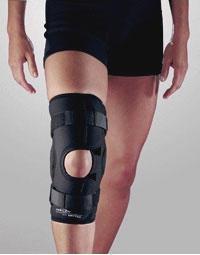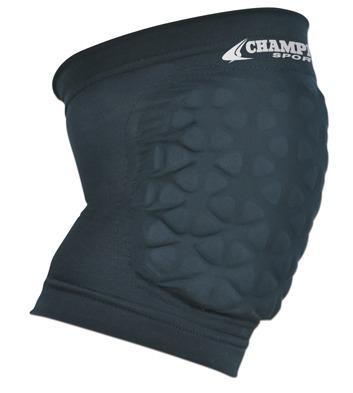The first image is the image on the left, the second image is the image on the right. Assess this claim about the two images: "one of the male legs has a brace, the other is bare". Correct or not? Answer yes or no. Yes. The first image is the image on the left, the second image is the image on the right. For the images shown, is this caption "All images featuring kneepads include human legs." true? Answer yes or no. No. 